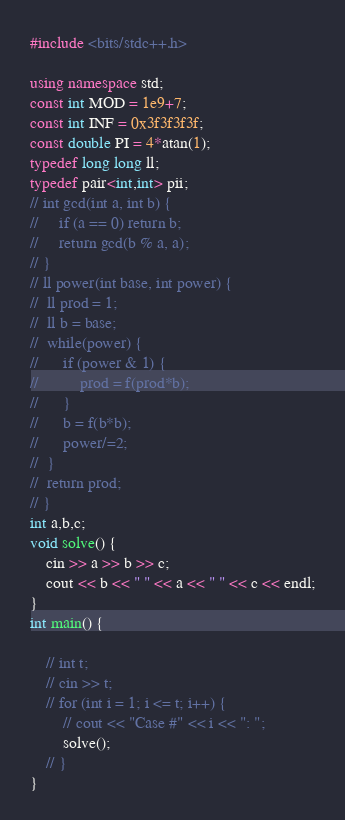Convert code to text. <code><loc_0><loc_0><loc_500><loc_500><_C++_>#include <bits/stdc++.h>
 
using namespace std;
const int MOD = 1e9+7;
const int INF = 0x3f3f3f3f;
const double PI = 4*atan(1);
typedef long long ll;
typedef pair<int,int> pii;
// int gcd(int a, int b) { 
//     if (a == 0) return b; 
//     return gcd(b % a, a); 
// }
// ll power(int base, int power) {
// 	ll prod = 1;
// 	ll b = base;
// 	while(power) {
// 		if (power & 1) {
// 			prod = f(prod*b);
// 		}
// 		b = f(b*b);
// 		power/=2;
// 	}
// 	return prod;
// }
int a,b,c;
void solve() {
	cin >> a >> b >> c;
	cout << b << " " << a << " " << c << endl;
}
int main() {

	// int t;
	// cin >> t;
	// for (int i = 1; i <= t; i++) { 
		// cout << "Case #" << i << ": ";
		solve();
	// }
}</code> 